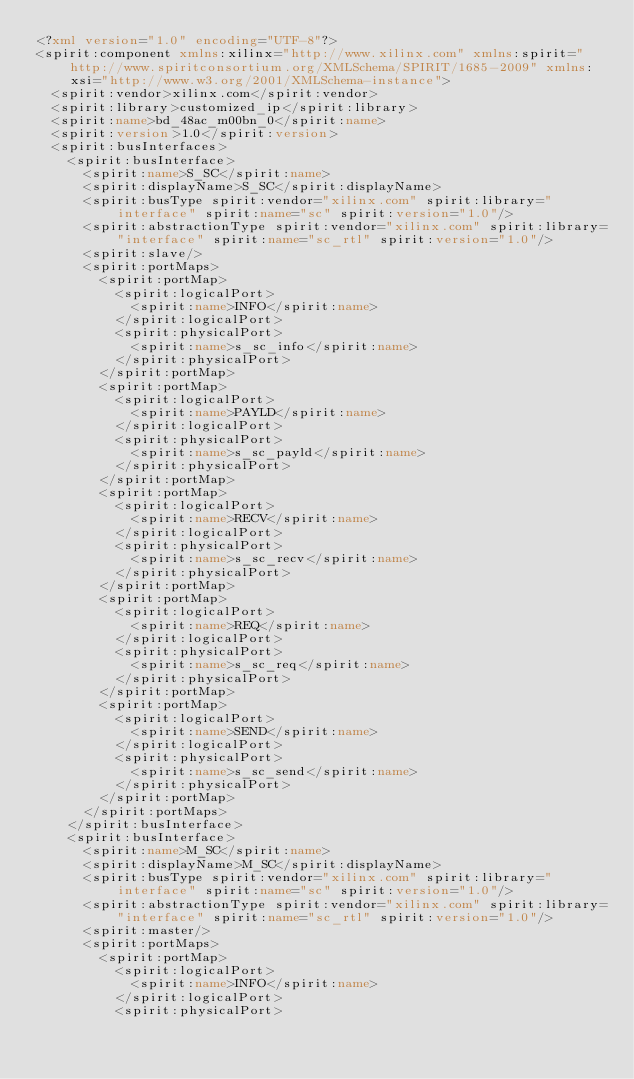<code> <loc_0><loc_0><loc_500><loc_500><_XML_><?xml version="1.0" encoding="UTF-8"?>
<spirit:component xmlns:xilinx="http://www.xilinx.com" xmlns:spirit="http://www.spiritconsortium.org/XMLSchema/SPIRIT/1685-2009" xmlns:xsi="http://www.w3.org/2001/XMLSchema-instance">
  <spirit:vendor>xilinx.com</spirit:vendor>
  <spirit:library>customized_ip</spirit:library>
  <spirit:name>bd_48ac_m00bn_0</spirit:name>
  <spirit:version>1.0</spirit:version>
  <spirit:busInterfaces>
    <spirit:busInterface>
      <spirit:name>S_SC</spirit:name>
      <spirit:displayName>S_SC</spirit:displayName>
      <spirit:busType spirit:vendor="xilinx.com" spirit:library="interface" spirit:name="sc" spirit:version="1.0"/>
      <spirit:abstractionType spirit:vendor="xilinx.com" spirit:library="interface" spirit:name="sc_rtl" spirit:version="1.0"/>
      <spirit:slave/>
      <spirit:portMaps>
        <spirit:portMap>
          <spirit:logicalPort>
            <spirit:name>INFO</spirit:name>
          </spirit:logicalPort>
          <spirit:physicalPort>
            <spirit:name>s_sc_info</spirit:name>
          </spirit:physicalPort>
        </spirit:portMap>
        <spirit:portMap>
          <spirit:logicalPort>
            <spirit:name>PAYLD</spirit:name>
          </spirit:logicalPort>
          <spirit:physicalPort>
            <spirit:name>s_sc_payld</spirit:name>
          </spirit:physicalPort>
        </spirit:portMap>
        <spirit:portMap>
          <spirit:logicalPort>
            <spirit:name>RECV</spirit:name>
          </spirit:logicalPort>
          <spirit:physicalPort>
            <spirit:name>s_sc_recv</spirit:name>
          </spirit:physicalPort>
        </spirit:portMap>
        <spirit:portMap>
          <spirit:logicalPort>
            <spirit:name>REQ</spirit:name>
          </spirit:logicalPort>
          <spirit:physicalPort>
            <spirit:name>s_sc_req</spirit:name>
          </spirit:physicalPort>
        </spirit:portMap>
        <spirit:portMap>
          <spirit:logicalPort>
            <spirit:name>SEND</spirit:name>
          </spirit:logicalPort>
          <spirit:physicalPort>
            <spirit:name>s_sc_send</spirit:name>
          </spirit:physicalPort>
        </spirit:portMap>
      </spirit:portMaps>
    </spirit:busInterface>
    <spirit:busInterface>
      <spirit:name>M_SC</spirit:name>
      <spirit:displayName>M_SC</spirit:displayName>
      <spirit:busType spirit:vendor="xilinx.com" spirit:library="interface" spirit:name="sc" spirit:version="1.0"/>
      <spirit:abstractionType spirit:vendor="xilinx.com" spirit:library="interface" spirit:name="sc_rtl" spirit:version="1.0"/>
      <spirit:master/>
      <spirit:portMaps>
        <spirit:portMap>
          <spirit:logicalPort>
            <spirit:name>INFO</spirit:name>
          </spirit:logicalPort>
          <spirit:physicalPort></code> 